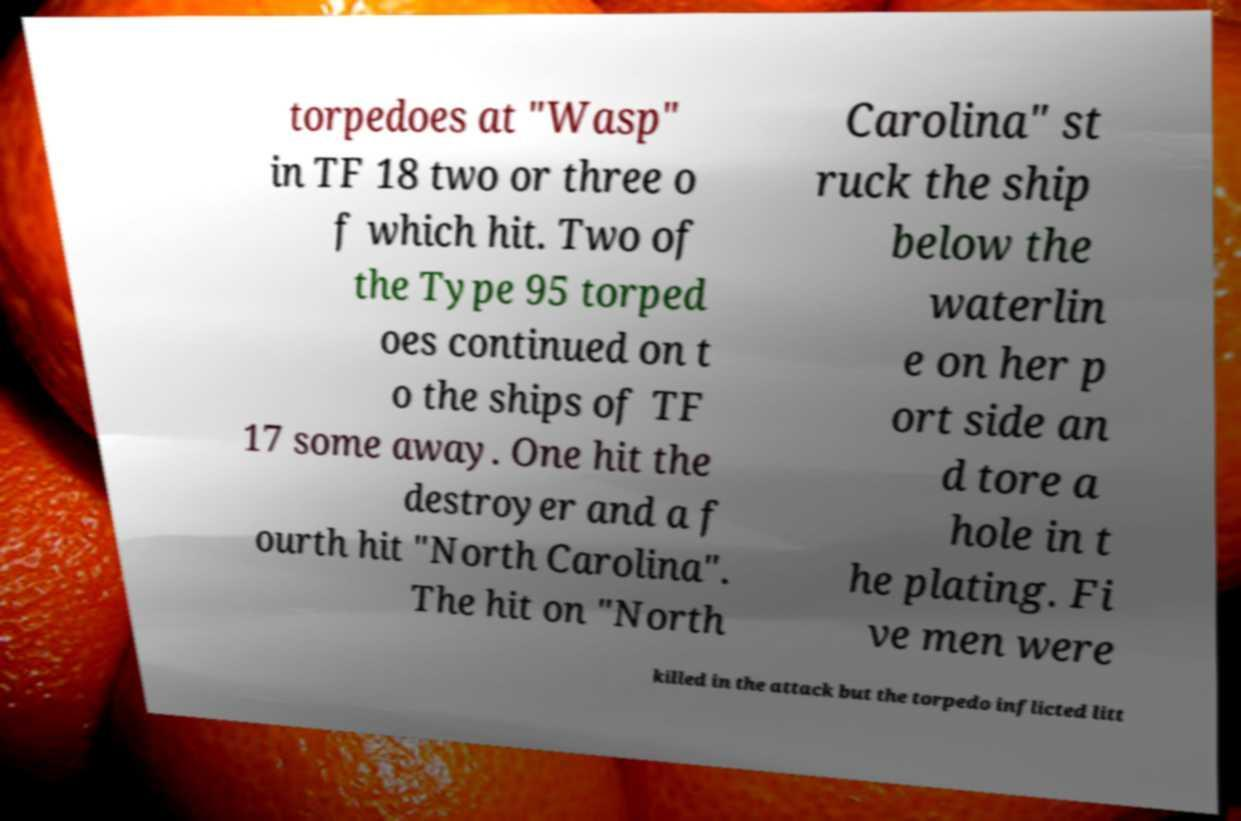I need the written content from this picture converted into text. Can you do that? torpedoes at "Wasp" in TF 18 two or three o f which hit. Two of the Type 95 torped oes continued on t o the ships of TF 17 some away. One hit the destroyer and a f ourth hit "North Carolina". The hit on "North Carolina" st ruck the ship below the waterlin e on her p ort side an d tore a hole in t he plating. Fi ve men were killed in the attack but the torpedo inflicted litt 